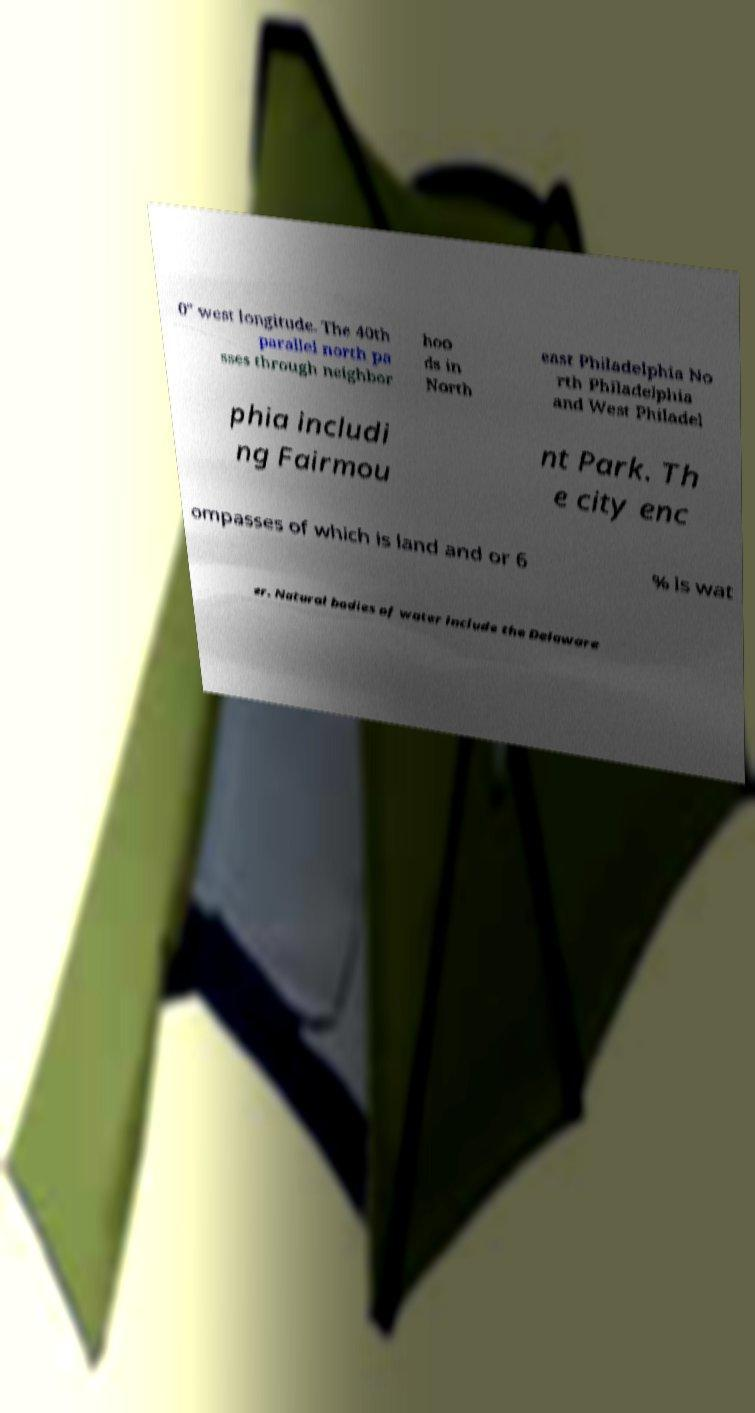I need the written content from this picture converted into text. Can you do that? 0″ west longitude. The 40th parallel north pa sses through neighbor hoo ds in North east Philadelphia No rth Philadelphia and West Philadel phia includi ng Fairmou nt Park. Th e city enc ompasses of which is land and or 6 % is wat er. Natural bodies of water include the Delaware 